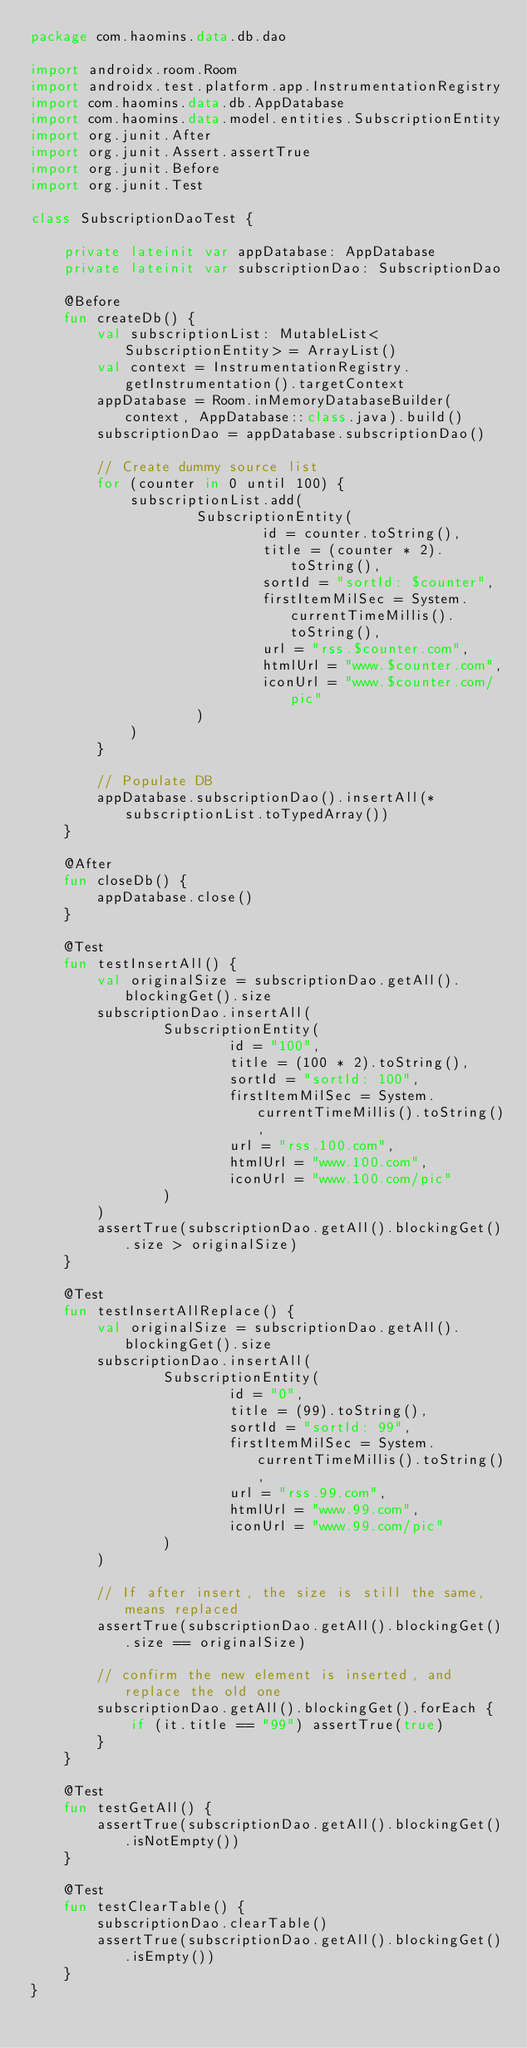Convert code to text. <code><loc_0><loc_0><loc_500><loc_500><_Kotlin_>package com.haomins.data.db.dao

import androidx.room.Room
import androidx.test.platform.app.InstrumentationRegistry
import com.haomins.data.db.AppDatabase
import com.haomins.data.model.entities.SubscriptionEntity
import org.junit.After
import org.junit.Assert.assertTrue
import org.junit.Before
import org.junit.Test

class SubscriptionDaoTest {

    private lateinit var appDatabase: AppDatabase
    private lateinit var subscriptionDao: SubscriptionDao

    @Before
    fun createDb() {
        val subscriptionList: MutableList<SubscriptionEntity> = ArrayList()
        val context = InstrumentationRegistry.getInstrumentation().targetContext
        appDatabase = Room.inMemoryDatabaseBuilder(context, AppDatabase::class.java).build()
        subscriptionDao = appDatabase.subscriptionDao()

        // Create dummy source list
        for (counter in 0 until 100) {
            subscriptionList.add(
                    SubscriptionEntity(
                            id = counter.toString(),
                            title = (counter * 2).toString(),
                            sortId = "sortId: $counter",
                            firstItemMilSec = System.currentTimeMillis().toString(),
                            url = "rss.$counter.com",
                            htmlUrl = "www.$counter.com",
                            iconUrl = "www.$counter.com/pic"
                    )
            )
        }

        // Populate DB
        appDatabase.subscriptionDao().insertAll(*subscriptionList.toTypedArray())
    }

    @After
    fun closeDb() {
        appDatabase.close()
    }

    @Test
    fun testInsertAll() {
        val originalSize = subscriptionDao.getAll().blockingGet().size
        subscriptionDao.insertAll(
                SubscriptionEntity(
                        id = "100",
                        title = (100 * 2).toString(),
                        sortId = "sortId: 100",
                        firstItemMilSec = System.currentTimeMillis().toString(),
                        url = "rss.100.com",
                        htmlUrl = "www.100.com",
                        iconUrl = "www.100.com/pic"
                )
        )
        assertTrue(subscriptionDao.getAll().blockingGet().size > originalSize)
    }

    @Test
    fun testInsertAllReplace() {
        val originalSize = subscriptionDao.getAll().blockingGet().size
        subscriptionDao.insertAll(
                SubscriptionEntity(
                        id = "0",
                        title = (99).toString(),
                        sortId = "sortId: 99",
                        firstItemMilSec = System.currentTimeMillis().toString(),
                        url = "rss.99.com",
                        htmlUrl = "www.99.com",
                        iconUrl = "www.99.com/pic"
                )
        )

        // If after insert, the size is still the same, means replaced
        assertTrue(subscriptionDao.getAll().blockingGet().size == originalSize)

        // confirm the new element is inserted, and replace the old one
        subscriptionDao.getAll().blockingGet().forEach {
            if (it.title == "99") assertTrue(true)
        }
    }

    @Test
    fun testGetAll() {
        assertTrue(subscriptionDao.getAll().blockingGet().isNotEmpty())
    }

    @Test
    fun testClearTable() {
        subscriptionDao.clearTable()
        assertTrue(subscriptionDao.getAll().blockingGet().isEmpty())
    }
}</code> 